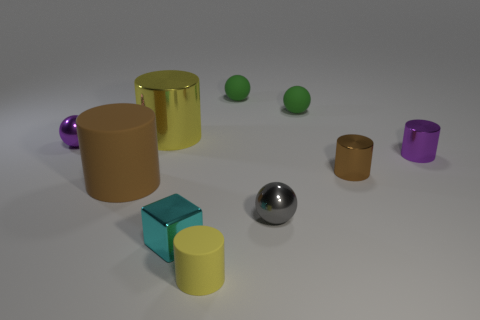There is a cylinder that is both to the left of the tiny gray object and on the right side of the big yellow thing; how big is it?
Provide a succinct answer. Small. There is a gray metal object that is to the right of the tiny purple shiny thing on the left side of the big thing behind the purple sphere; what size is it?
Offer a very short reply. Small. How many other things are there of the same color as the small cube?
Provide a succinct answer. 0. Does the small sphere that is in front of the brown rubber cylinder have the same color as the tiny cube?
Provide a succinct answer. No. What number of things are yellow metallic objects or small cyan blocks?
Your answer should be compact. 2. There is a matte cylinder that is left of the tiny yellow cylinder; what is its color?
Your response must be concise. Brown. Is the number of small things on the right side of the small brown metal cylinder less than the number of small rubber things?
Your answer should be very brief. Yes. There is a matte object that is the same color as the big metal thing; what size is it?
Your response must be concise. Small. Is there anything else that has the same size as the brown rubber cylinder?
Your answer should be compact. Yes. Is the material of the tiny cyan block the same as the gray sphere?
Your answer should be very brief. Yes. 